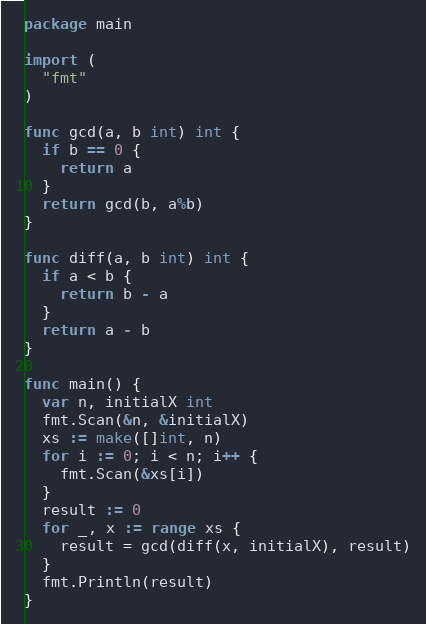<code> <loc_0><loc_0><loc_500><loc_500><_Go_>package main

import (
  "fmt"
)

func gcd(a, b int) int {
  if b == 0 {
    return a
  }
  return gcd(b, a%b)
}

func diff(a, b int) int {
  if a < b {
    return b - a
  }
  return a - b
}

func main() {
  var n, initialX int
  fmt.Scan(&n, &initialX)
  xs := make([]int, n)
  for i := 0; i < n; i++ {
    fmt.Scan(&xs[i])
  }
  result := 0
  for _, x := range xs {
    result = gcd(diff(x, initialX), result)
  }
  fmt.Println(result)  
}</code> 